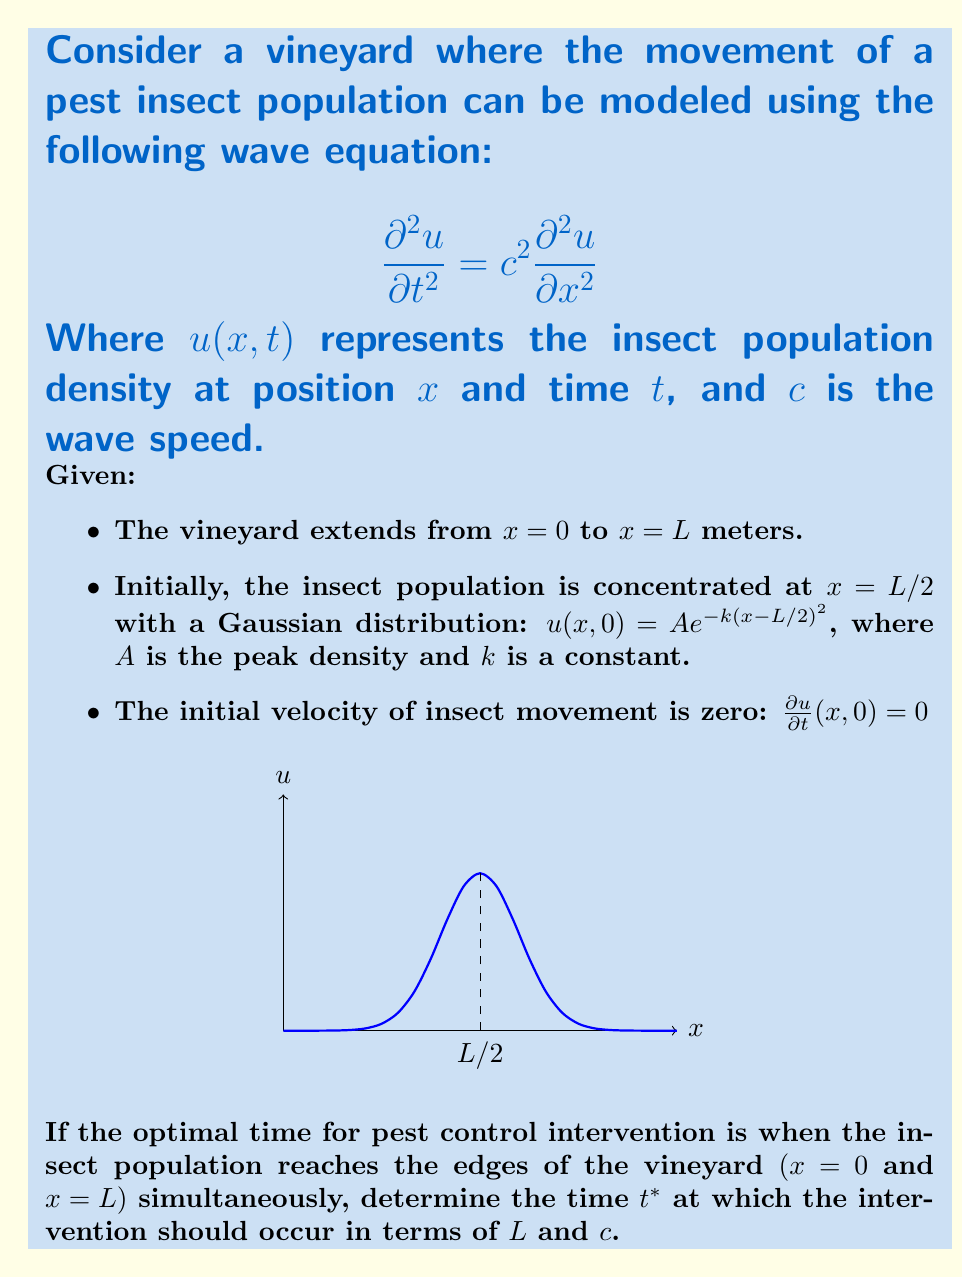Provide a solution to this math problem. To solve this problem, we need to analyze the wave equation and its solution for the given initial conditions. Let's approach this step-by-step:

1) The general solution to the 1D wave equation is given by d'Alembert's formula:

   $$u(x,t) = \frac{1}{2}[f(x-ct) + f(x+ct)] + \frac{1}{2c}\int_{x-ct}^{x+ct} g(s)ds$$

   Where $f(x)$ is the initial displacement and $g(x)$ is the initial velocity.

2) In our case, $f(x) = Ae^{-k(x-L/2)^2}$ and $g(x) = 0$.

3) Substituting these into d'Alembert's formula:

   $$u(x,t) = \frac{1}{2}[Ae^{-k((x-ct)-L/2)^2} + Ae^{-k((x+ct)-L/2)^2}]$$

4) The pest control intervention should occur when the waves reach both ends of the vineyard simultaneously. Due to symmetry, this will happen when the waves travel a distance of $L/2$.

5) The time taken for the wave to travel this distance is:

   $$t^* = \frac{L/2}{c}$$

6) At this time, the population at $x=0$ and $x=L$ will be non-zero, indicating the arrival of the insect population at the edges of the vineyard.

Therefore, the optimal time for pest control intervention is when $t = L/(2c)$.
Answer: $t^* = \frac{L}{2c}$ 